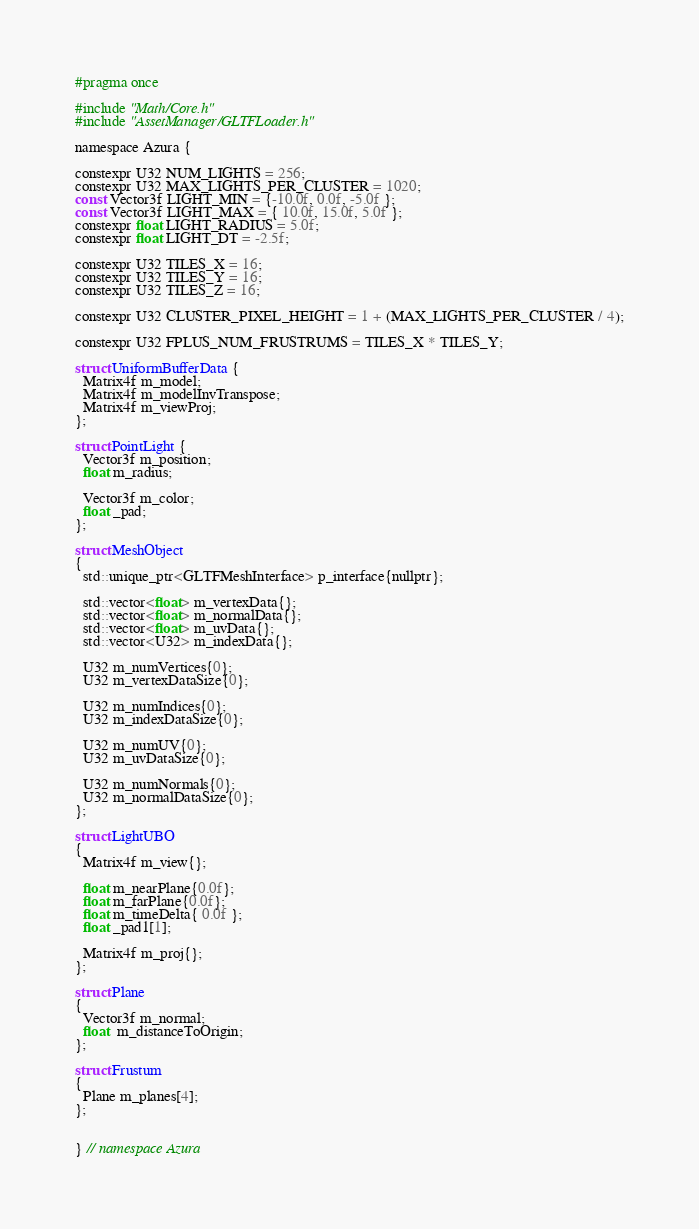<code> <loc_0><loc_0><loc_500><loc_500><_C_>#pragma once

#include "Math/Core.h"
#include "AssetManager/GLTFLoader.h"

namespace Azura {

constexpr U32 NUM_LIGHTS = 256;
constexpr U32 MAX_LIGHTS_PER_CLUSTER = 1020;
const Vector3f LIGHT_MIN = {-10.0f, 0.0f, -5.0f };
const Vector3f LIGHT_MAX = { 10.0f, 15.0f, 5.0f };
constexpr float LIGHT_RADIUS = 5.0f;
constexpr float LIGHT_DT = -2.5f;

constexpr U32 TILES_X = 16;
constexpr U32 TILES_Y = 16;
constexpr U32 TILES_Z = 16;

constexpr U32 CLUSTER_PIXEL_HEIGHT = 1 + (MAX_LIGHTS_PER_CLUSTER / 4);

constexpr U32 FPLUS_NUM_FRUSTRUMS = TILES_X * TILES_Y;

struct UniformBufferData {
  Matrix4f m_model;
  Matrix4f m_modelInvTranspose;
  Matrix4f m_viewProj;
};

struct PointLight {
  Vector3f m_position;
  float m_radius;

  Vector3f m_color;
  float _pad;
};

struct MeshObject
{
  std::unique_ptr<GLTFMeshInterface> p_interface{nullptr};

  std::vector<float> m_vertexData{};
  std::vector<float> m_normalData{};
  std::vector<float> m_uvData{};
  std::vector<U32> m_indexData{};

  U32 m_numVertices{0};
  U32 m_vertexDataSize{0};

  U32 m_numIndices{0};
  U32 m_indexDataSize{0};

  U32 m_numUV{0};
  U32 m_uvDataSize{0};

  U32 m_numNormals{0};
  U32 m_normalDataSize{0};
};

struct LightUBO
{
  Matrix4f m_view{};

  float m_nearPlane{0.0f};
  float m_farPlane{0.0f};
  float m_timeDelta{ 0.0f };
  float _pad1[1];

  Matrix4f m_proj{};
};

struct Plane
{
  Vector3f m_normal;
  float  m_distanceToOrigin;
};

struct Frustum
{
  Plane m_planes[4];
};


} // namespace Azura</code> 